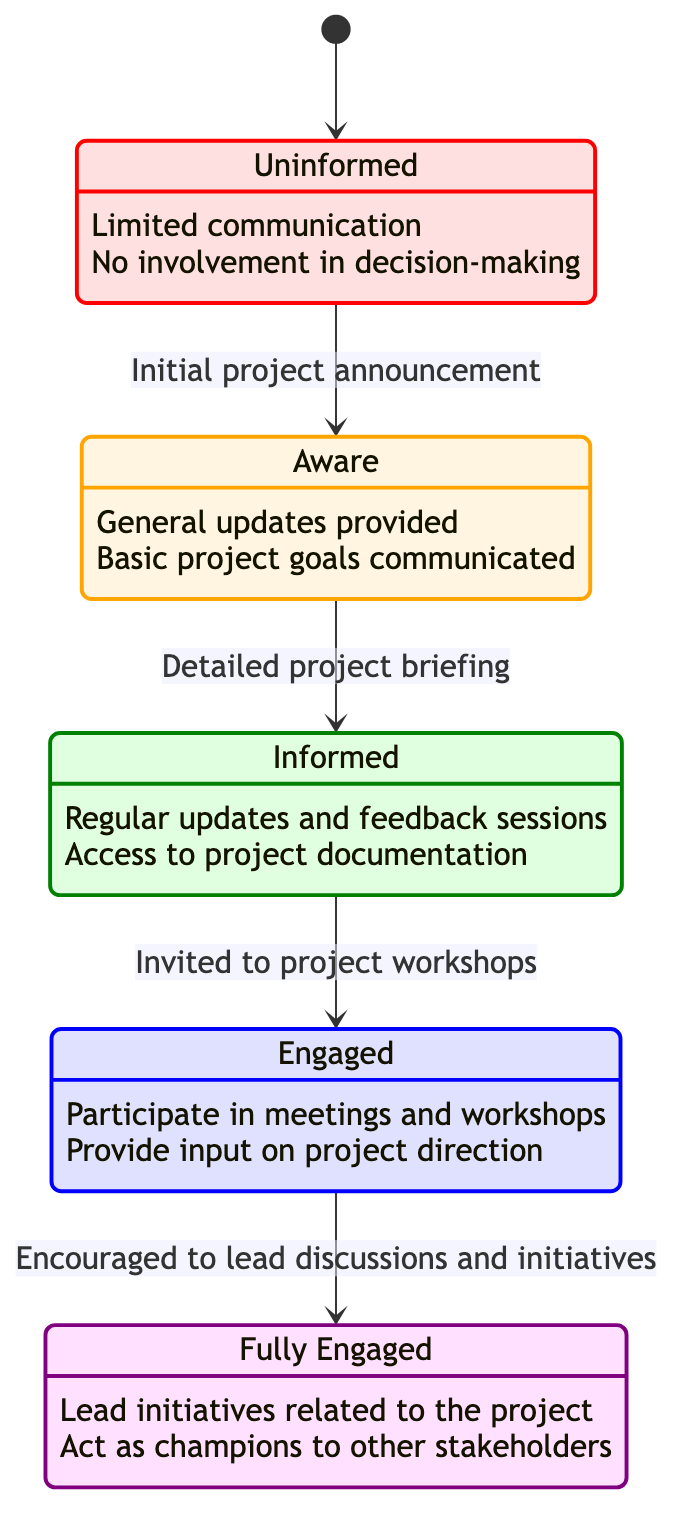What's the starting state in the diagram? The diagram initiates from the state labeled "Uninformed", which is represented by the arrow from the initial point to Uninformed.
Answer: Uninformed How many total states are represented in the diagram? By counting each distinct state listed in the diagram, there are five states: Uninformed, Aware, Informed, Engaged, Fully Engaged.
Answer: 5 What is the trigger for the transition from Aware to Informed? The description under the transition from Aware to Informed states "Detailed project briefing" as the action that initiates this transition.
Answer: Detailed project briefing Which state involves stakeholders leading initiatives related to the project? In the state description, "Fully Engaged" explicitly mentions that stakeholders lead initiatives related to the project, indicating active leadership.
Answer: Fully Engaged What characteristic is associated with the Engaged state? The Engaged state includes the characteristic "Participate in meetings and workshops", showcasing the involvement expected at this level.
Answer: Participate in meetings and workshops What is the relationship between Informed and Engaged? The transition from Informed to Engaged indicates an evolution after stakeholders are invited to project workshops, highlighting the process of increasing involvement.
Answer: Invited to project workshops What is the final state stakeholders can achieve in the diagram? The diagram shows that the last point in the transition flow is "Fully Engaged", which signifies the highest level of stakeholder involvement.
Answer: Fully Engaged What characteristics define the Aware state? The "Aware" state is characterized by "General updates provided" and "Basic project goals communicated," indicating the level of information shared.
Answer: General updates provided, Basic project goals communicated 